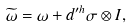Convert formula to latex. <formula><loc_0><loc_0><loc_500><loc_500>\widetilde { \omega } = \omega + d ^ { \prime h } \sigma \otimes I ,</formula> 